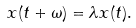<formula> <loc_0><loc_0><loc_500><loc_500>x ( t + \omega ) = \lambda x ( t ) .</formula> 